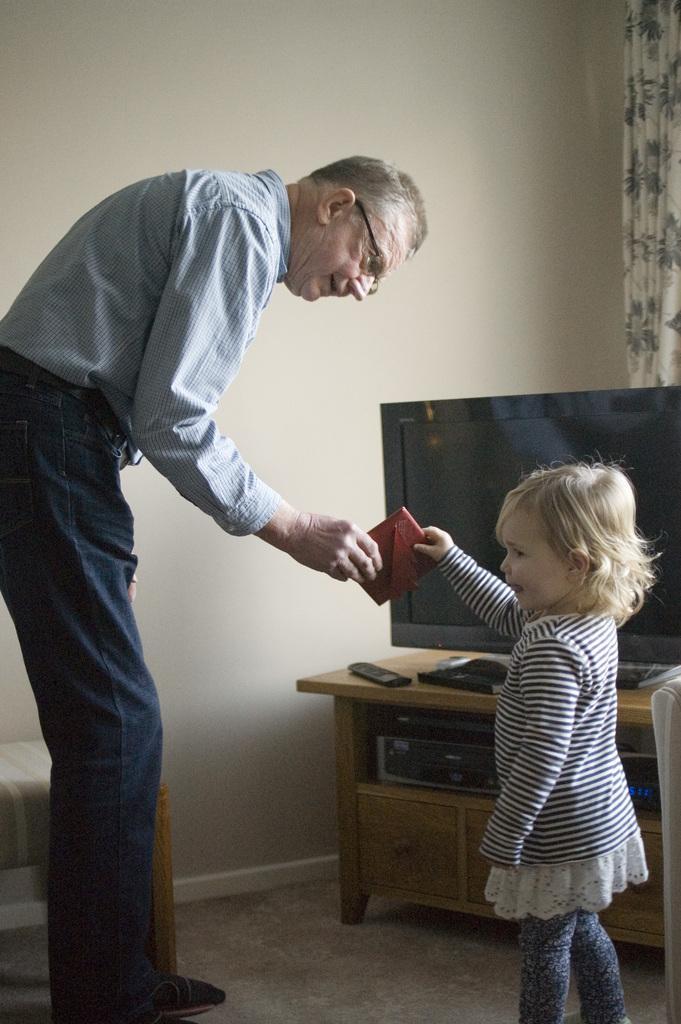Describe this image in one or two sentences. There is an old man in the picture bending and giving purse to little girl with blond hair. The backside there is table to left corner and a tv on it with a remote. To the whole background there is flower curtain. 